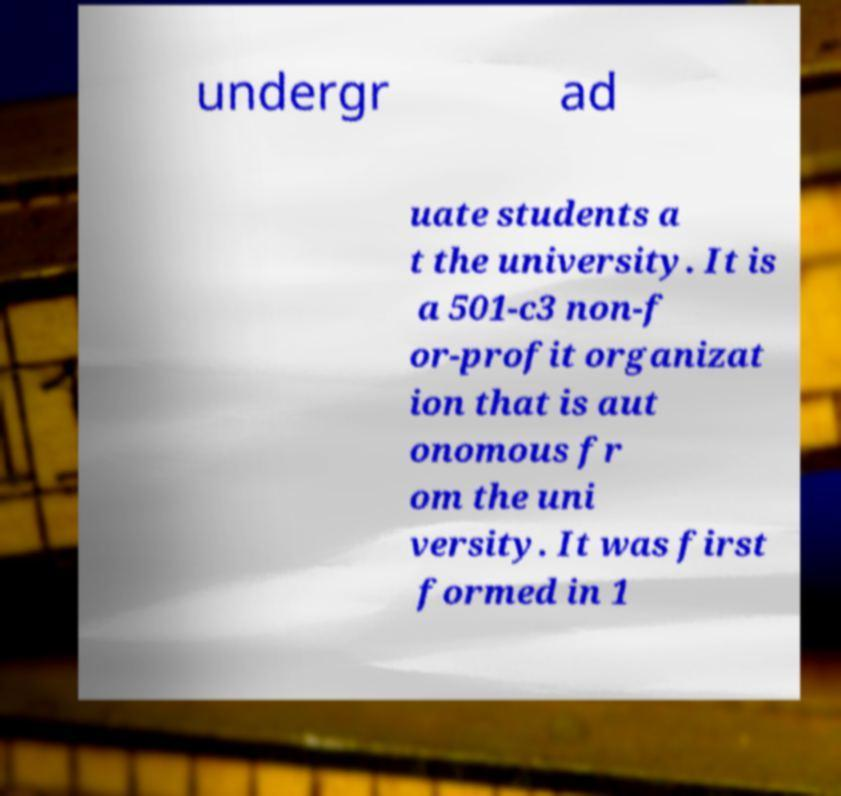There's text embedded in this image that I need extracted. Can you transcribe it verbatim? undergr ad uate students a t the university. It is a 501-c3 non-f or-profit organizat ion that is aut onomous fr om the uni versity. It was first formed in 1 